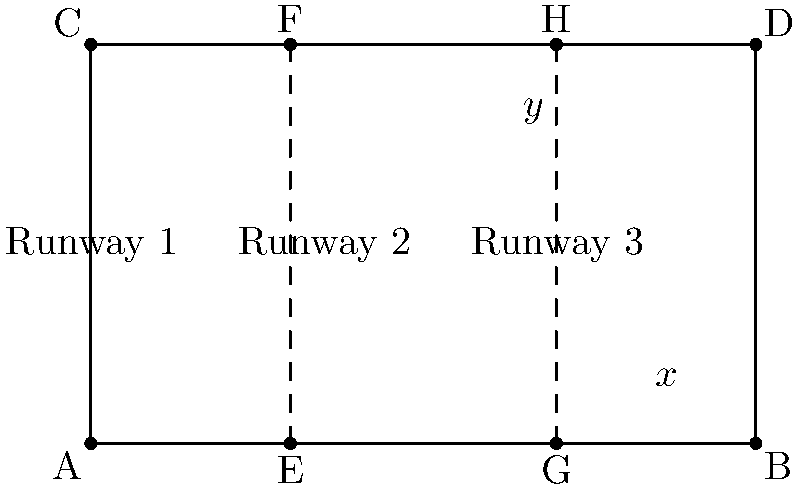In this "Absolutely Fabulous" inspired fashion runway layout, three parallel runways are intersected by the main stage line. If the angle marked $x°$ is 65°, what is the value of $y°$? Let's solve this step-by-step using the properties of parallel lines intersected by a transversal:

1) In this diagram, the three runways are parallel to each other, and the main stage line acts as a transversal.

2) When parallel lines are cut by a transversal, corresponding angles are congruent.

3) The angle marked $x°$ and the angle marked $y°$ are corresponding angles.

4) Therefore, $x° = y°$

5) We are given that $x° = 65°$

6) Since $x° = y°$, we can conclude that $y° = 65°$ as well.

This concept of corresponding angles being equal is similar to how Patsy and Edina always dress correspondingly fabulous in "Absolutely Fabulous"!
Answer: $65°$ 